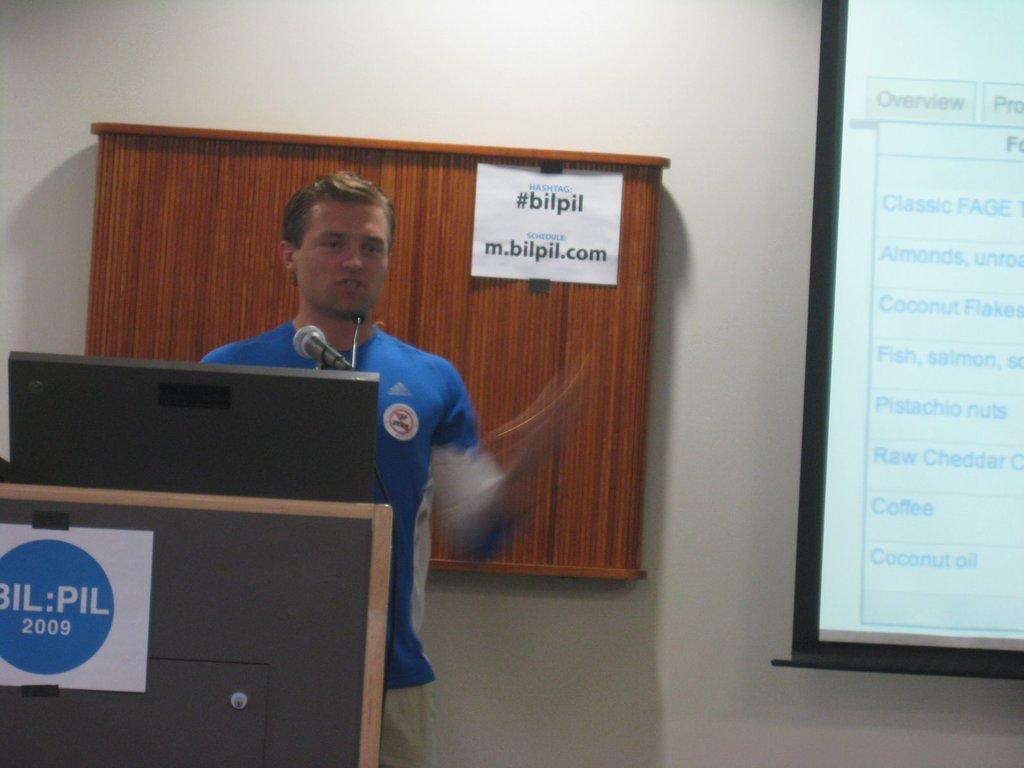In one or two sentences, can you explain what this image depicts? In this image I can see a man is standing. I can see he is wearing blue dress. I can also see a mic, a projector screen and I can see something is written at few places. 